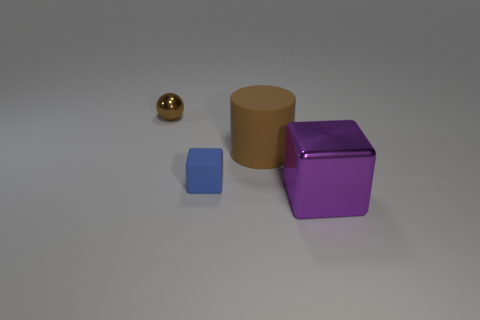Can you describe the color of the largest object? The largest object in the image is a cylindrical shape with a hue resembling that of coffee with cream, or a light brown. 